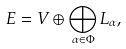Convert formula to latex. <formula><loc_0><loc_0><loc_500><loc_500>E = V \oplus \bigoplus _ { \alpha \in \Phi } L _ { \alpha } ,</formula> 